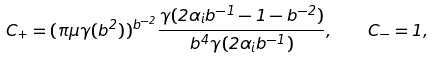<formula> <loc_0><loc_0><loc_500><loc_500>C _ { + } = ( \pi \mu \gamma ( b ^ { 2 } ) ) ^ { b ^ { - 2 } } \frac { \gamma ( 2 \alpha _ { i } b ^ { - 1 } - 1 - b ^ { - 2 } ) } { b ^ { 4 } \gamma ( 2 \alpha _ { i } b ^ { - 1 } ) } , \quad C _ { - } = 1 ,</formula> 